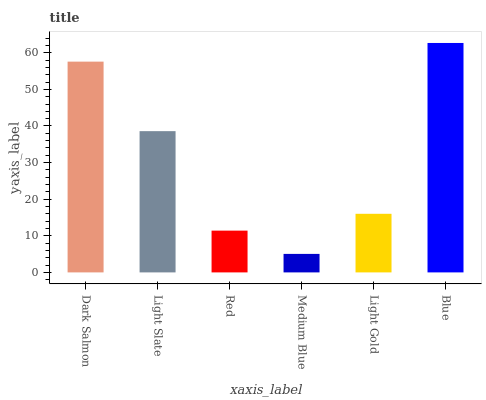Is Medium Blue the minimum?
Answer yes or no. Yes. Is Blue the maximum?
Answer yes or no. Yes. Is Light Slate the minimum?
Answer yes or no. No. Is Light Slate the maximum?
Answer yes or no. No. Is Dark Salmon greater than Light Slate?
Answer yes or no. Yes. Is Light Slate less than Dark Salmon?
Answer yes or no. Yes. Is Light Slate greater than Dark Salmon?
Answer yes or no. No. Is Dark Salmon less than Light Slate?
Answer yes or no. No. Is Light Slate the high median?
Answer yes or no. Yes. Is Light Gold the low median?
Answer yes or no. Yes. Is Dark Salmon the high median?
Answer yes or no. No. Is Blue the low median?
Answer yes or no. No. 